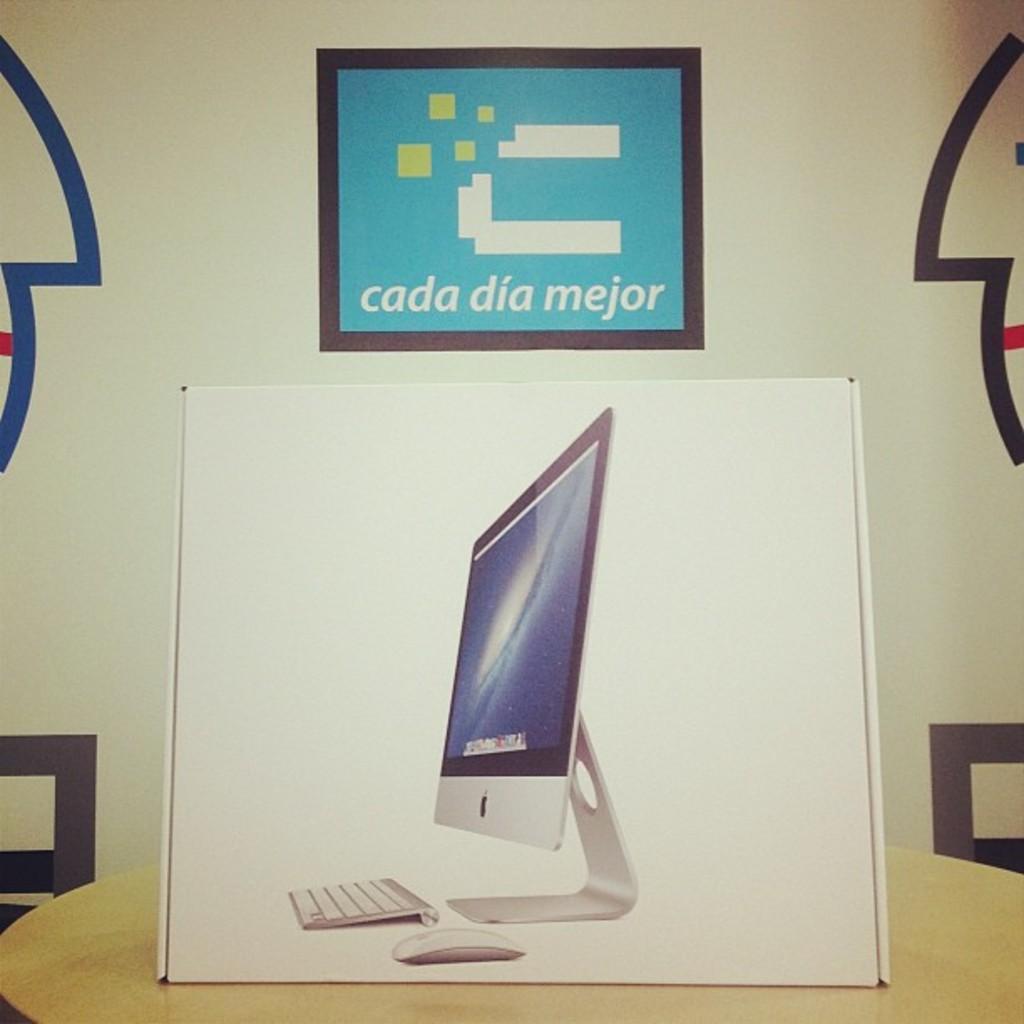Who makes that computer?
Provide a succinct answer. Cada dia mejor. What is written on the sign above the box?
Your response must be concise. Cada dia mejor. 